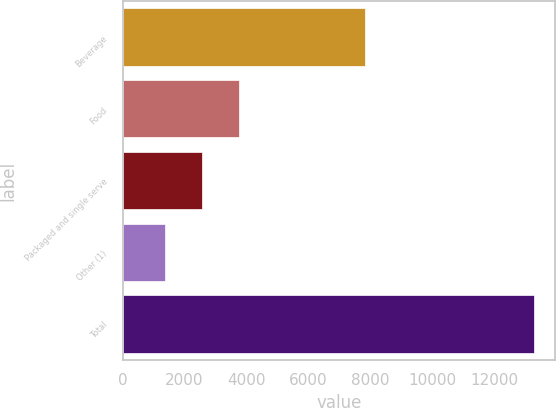Convert chart. <chart><loc_0><loc_0><loc_500><loc_500><bar_chart><fcel>Beverage<fcel>Food<fcel>Packaged and single serve<fcel>Other (1)<fcel>Total<nl><fcel>7838.8<fcel>3753.34<fcel>2560.07<fcel>1366.8<fcel>13299.5<nl></chart> 